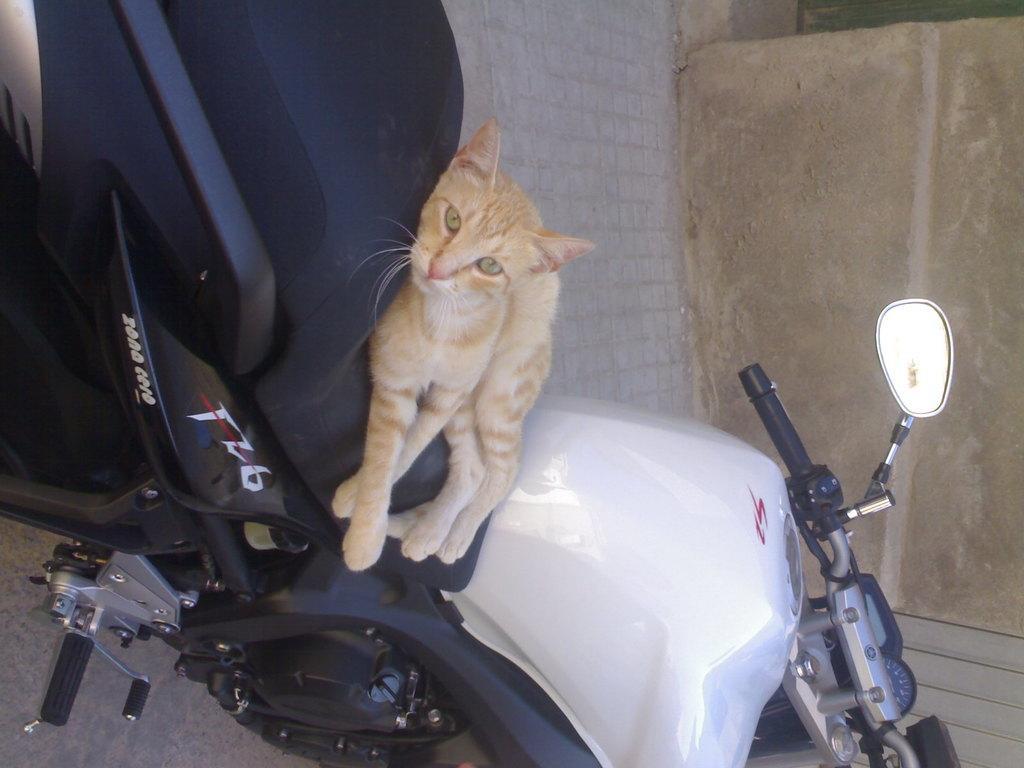How would you summarize this image in a sentence or two? This cat is laying on his motorbike, which is in black and white color. This motorcycle has handle, meter reading, mirror and stand. 